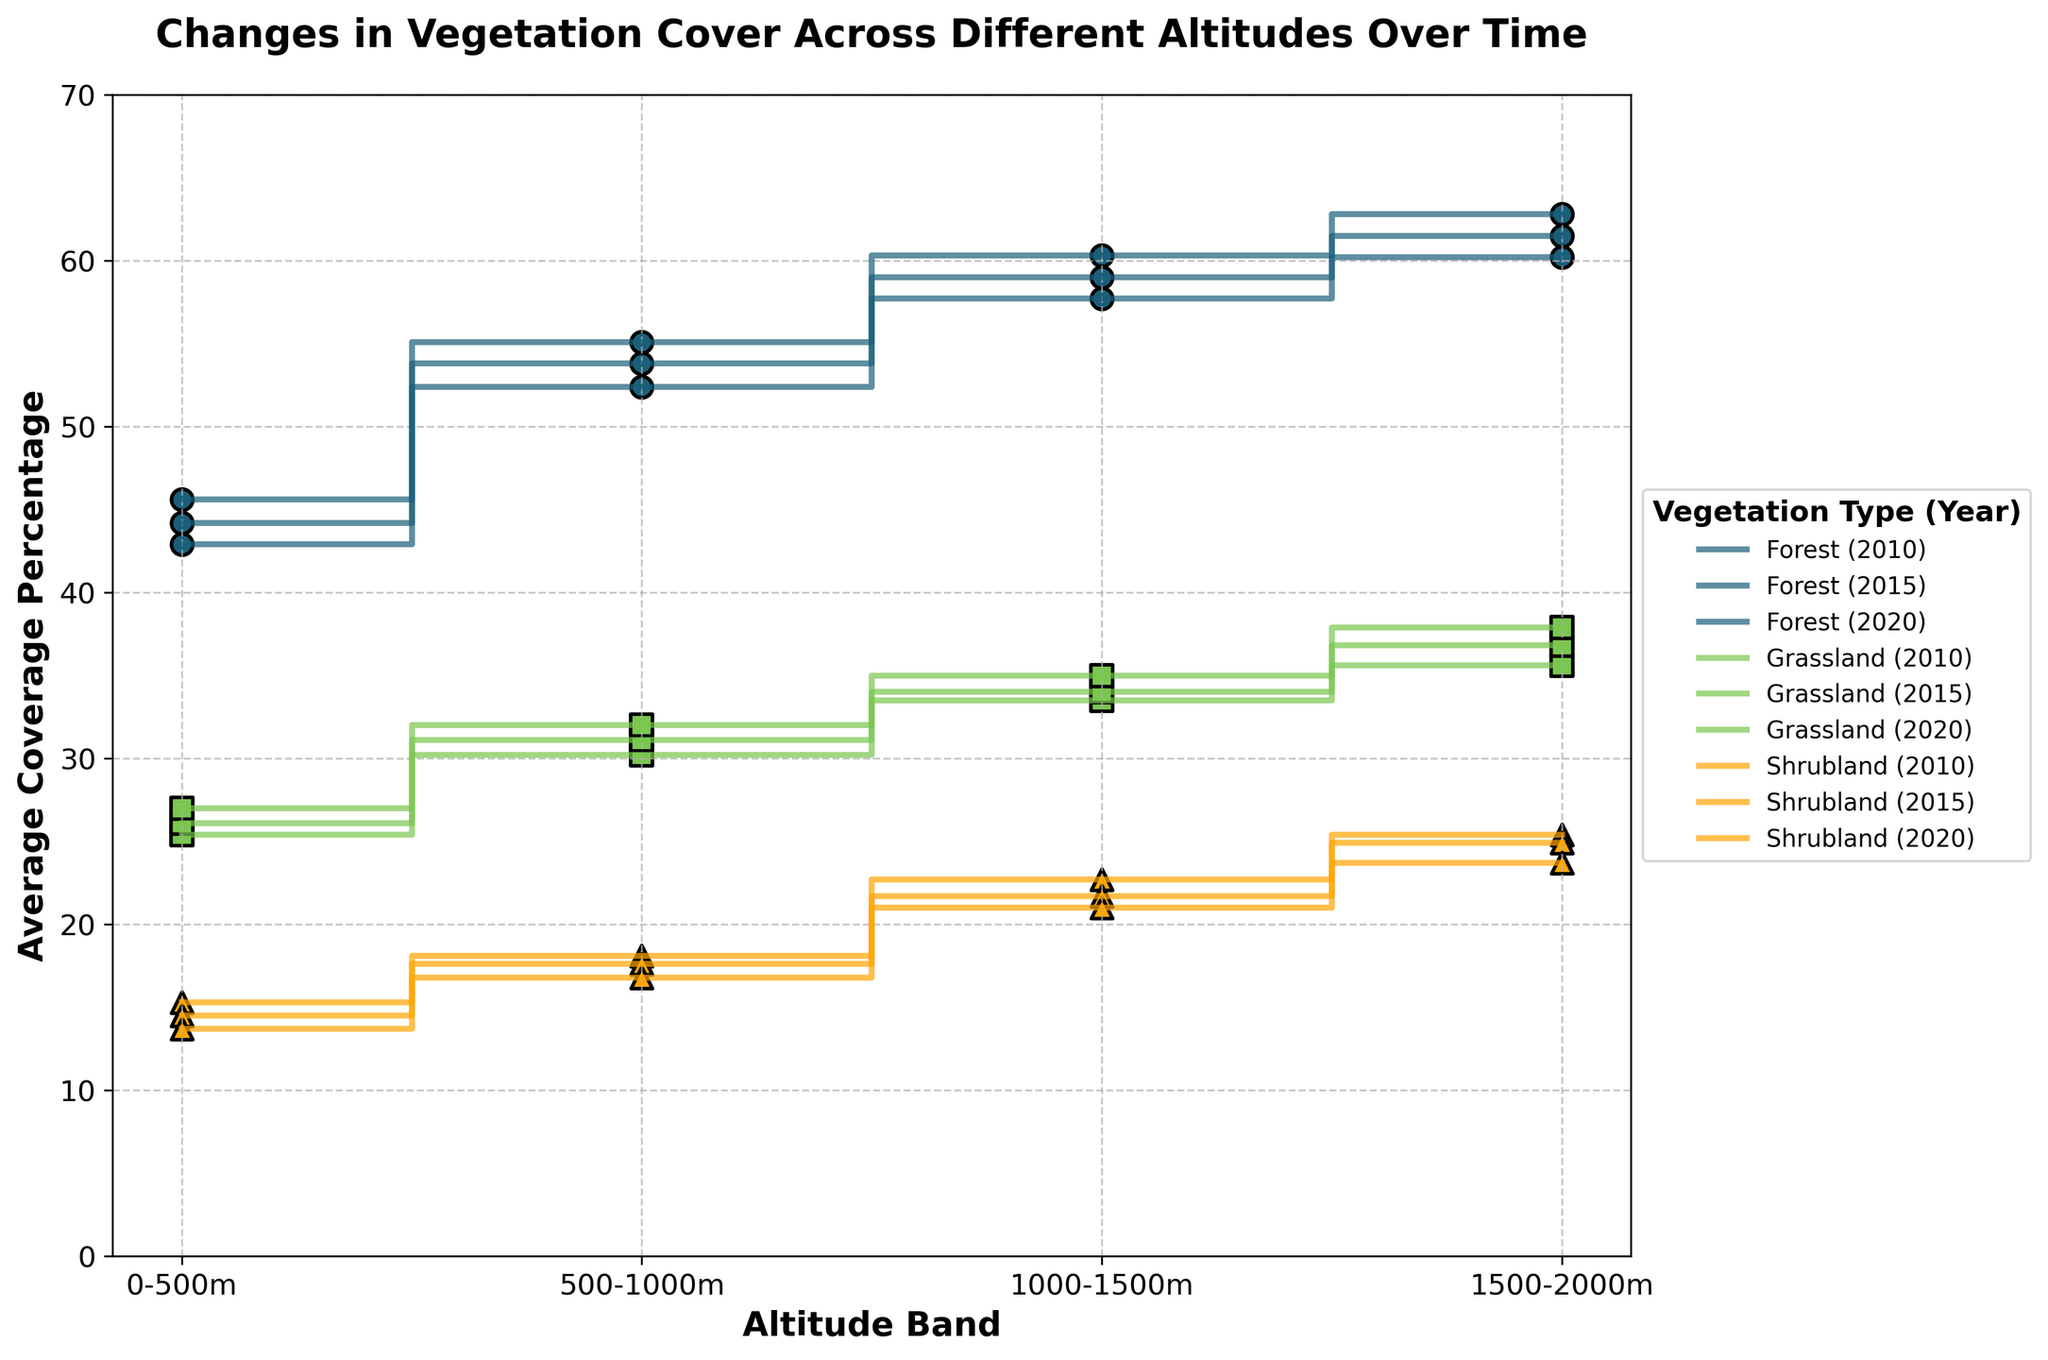What is the title of the plot? The title is typically placed at the top center part of the plot. Here, it reads "Changes in Vegetation Cover Across Different Altitudes Over Time."
Answer: Changes in Vegetation Cover Across Different Altitudes Over Time What is the maximum average coverage percentage observed in the plot? The maximum average coverage percentage can be found by looking at the highest point on the vertical axis (Average Coverage Percentage). In this case, it is around 62.8% for the Forest at 1500-2000m altitude in 2010.
Answer: 62.8% In which year did Grassland have the highest average coverage percentage? Locate the lines and markers for Grassland. Compare the highest coverage points across different years (2010, 2015, 2020). Grassland has its highest average coverage around 37.9% in 2020 at 1500-2000m altitude.
Answer: 2020 How did the average coverage of Shrubland at 0-500m change from 2010 to 2020? Observe the markers for Shrubland at 0-500m altitude in the years 2010, 2015, and 2020. In 2010, it was 15.3%; in 2015, it was 14.5%; and in 2020, it was 13.7%. The coverage decreased over the years.
Answer: Decreased Compare the trend of Forest and Grassland over different altitude bands in 2020. Locate the lines and markers for both Forest and Grassland for the year 2020 across different altitudes. Both show a general increase in coverage percentage with altitude. Forest increased from 42.9% to 60.2%, while Grassland increased from 27.0% to 37.9%.
Answer: Both increased with altitude What is the average percentage coverage of Grassland across all altitude bands in 2015? Sum the average coverage percentages of Grassland for each altitude band in 2015 (26.1 + 31.1 + 34.0 + 36.8), then divide by the number of bands (4). (26.1 + 31.1 + 34.0 + 36.8) = 128, so 128 / 4 = 32
Answer: 32% At which altitude band did all vegetation types show an increase in average coverage from 2010 to 2015? Compare the coverage percentages for each vegetation type at each altitude band from 2010 to 2015. All vegetation types at 1000-1500m and 1500-2000m show an increase in this period. For instance, Forest from 60.3 to 59.0, Grassland from 33.5 to 34.0, Shrubland from 22.7 to 21.7 (though rounded numbers show slight variations). This points to general increase trend.
Answer: 1500-2000m For which vegetation type is the difference in average coverage the least between the altitude bands 1000-1500m and 1500-2000m in 2020? Identify the coverage percentages for each vegetation type at these altitude bands for 2020. Calculate the absolute difference: Forest (60.2 - 57.7 = 2.5), Grassland (37.9 - 35.0 = 2.9), Shrubland (23.7 - 21.0 = 2.7). Forest has the least difference at 2.5.
Answer: Forest Which year showed the most significant decrease in coverage for Forest at 500-1000m altitude band? Look at the Forest coverage percentages at 500-1000m for each year. The biggest drop is from 2010 (55.1) to 2020 (52.4), which is a 2.7% decrease.
Answer: 2020 